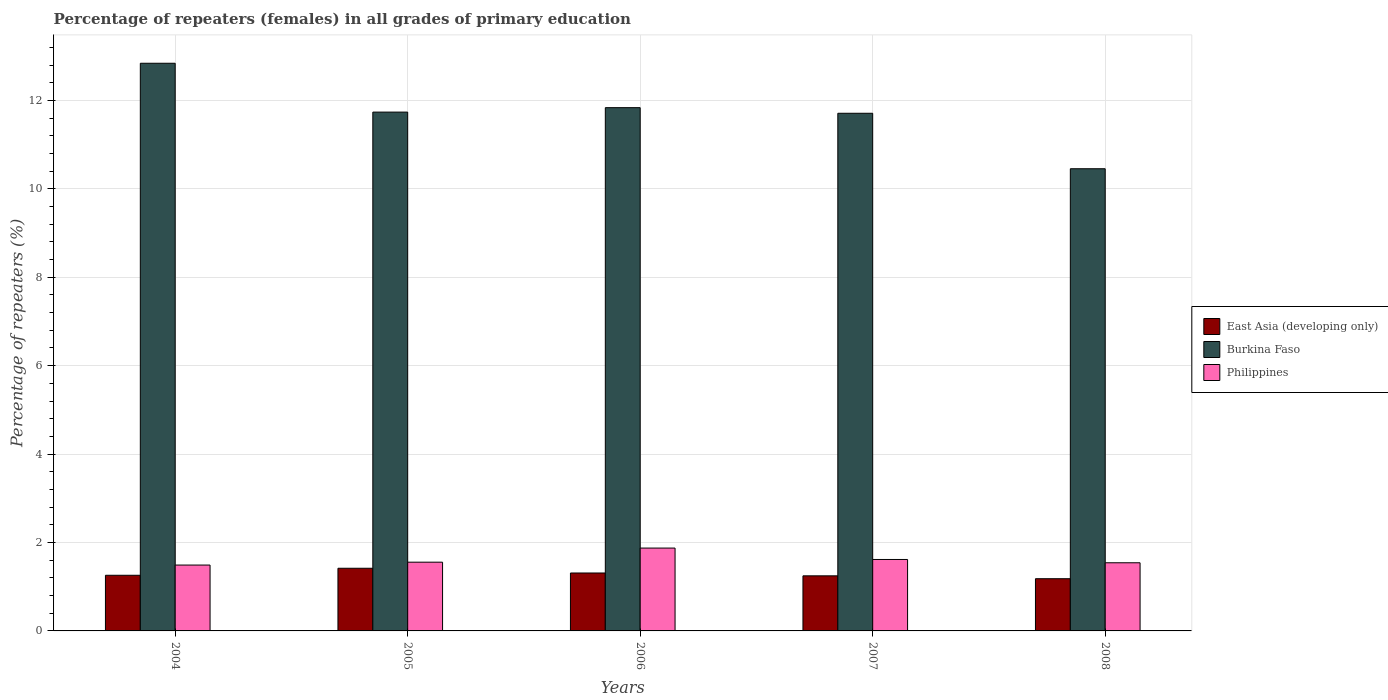How many different coloured bars are there?
Provide a succinct answer. 3. How many groups of bars are there?
Ensure brevity in your answer.  5. Are the number of bars on each tick of the X-axis equal?
Your answer should be compact. Yes. How many bars are there on the 2nd tick from the right?
Offer a terse response. 3. What is the label of the 3rd group of bars from the left?
Give a very brief answer. 2006. What is the percentage of repeaters (females) in Burkina Faso in 2004?
Provide a short and direct response. 12.84. Across all years, what is the maximum percentage of repeaters (females) in Philippines?
Your answer should be compact. 1.87. Across all years, what is the minimum percentage of repeaters (females) in Philippines?
Provide a succinct answer. 1.49. In which year was the percentage of repeaters (females) in Burkina Faso maximum?
Provide a short and direct response. 2004. In which year was the percentage of repeaters (females) in Philippines minimum?
Keep it short and to the point. 2004. What is the total percentage of repeaters (females) in Burkina Faso in the graph?
Your answer should be compact. 58.57. What is the difference between the percentage of repeaters (females) in Burkina Faso in 2006 and that in 2007?
Your answer should be compact. 0.13. What is the difference between the percentage of repeaters (females) in Philippines in 2008 and the percentage of repeaters (females) in East Asia (developing only) in 2004?
Provide a short and direct response. 0.28. What is the average percentage of repeaters (females) in Philippines per year?
Ensure brevity in your answer.  1.62. In the year 2005, what is the difference between the percentage of repeaters (females) in Burkina Faso and percentage of repeaters (females) in Philippines?
Offer a very short reply. 10.18. What is the ratio of the percentage of repeaters (females) in Burkina Faso in 2005 to that in 2006?
Your response must be concise. 0.99. Is the percentage of repeaters (females) in Burkina Faso in 2004 less than that in 2007?
Your answer should be very brief. No. What is the difference between the highest and the second highest percentage of repeaters (females) in Burkina Faso?
Your answer should be compact. 1. What is the difference between the highest and the lowest percentage of repeaters (females) in East Asia (developing only)?
Make the answer very short. 0.24. In how many years, is the percentage of repeaters (females) in Philippines greater than the average percentage of repeaters (females) in Philippines taken over all years?
Offer a very short reply. 2. What does the 2nd bar from the left in 2006 represents?
Your response must be concise. Burkina Faso. What does the 3rd bar from the right in 2006 represents?
Keep it short and to the point. East Asia (developing only). Are all the bars in the graph horizontal?
Ensure brevity in your answer.  No. What is the difference between two consecutive major ticks on the Y-axis?
Offer a very short reply. 2. Are the values on the major ticks of Y-axis written in scientific E-notation?
Your answer should be very brief. No. Does the graph contain any zero values?
Your answer should be very brief. No. Does the graph contain grids?
Give a very brief answer. Yes. Where does the legend appear in the graph?
Offer a terse response. Center right. What is the title of the graph?
Give a very brief answer. Percentage of repeaters (females) in all grades of primary education. Does "Tunisia" appear as one of the legend labels in the graph?
Give a very brief answer. No. What is the label or title of the Y-axis?
Your response must be concise. Percentage of repeaters (%). What is the Percentage of repeaters (%) in East Asia (developing only) in 2004?
Provide a short and direct response. 1.26. What is the Percentage of repeaters (%) in Burkina Faso in 2004?
Give a very brief answer. 12.84. What is the Percentage of repeaters (%) in Philippines in 2004?
Your answer should be compact. 1.49. What is the Percentage of repeaters (%) of East Asia (developing only) in 2005?
Provide a short and direct response. 1.42. What is the Percentage of repeaters (%) of Burkina Faso in 2005?
Ensure brevity in your answer.  11.73. What is the Percentage of repeaters (%) of Philippines in 2005?
Your answer should be compact. 1.55. What is the Percentage of repeaters (%) in East Asia (developing only) in 2006?
Ensure brevity in your answer.  1.31. What is the Percentage of repeaters (%) of Burkina Faso in 2006?
Give a very brief answer. 11.84. What is the Percentage of repeaters (%) in Philippines in 2006?
Make the answer very short. 1.87. What is the Percentage of repeaters (%) in East Asia (developing only) in 2007?
Provide a short and direct response. 1.25. What is the Percentage of repeaters (%) of Burkina Faso in 2007?
Your response must be concise. 11.71. What is the Percentage of repeaters (%) in Philippines in 2007?
Ensure brevity in your answer.  1.62. What is the Percentage of repeaters (%) in East Asia (developing only) in 2008?
Keep it short and to the point. 1.18. What is the Percentage of repeaters (%) in Burkina Faso in 2008?
Give a very brief answer. 10.45. What is the Percentage of repeaters (%) in Philippines in 2008?
Your answer should be compact. 1.54. Across all years, what is the maximum Percentage of repeaters (%) of East Asia (developing only)?
Provide a short and direct response. 1.42. Across all years, what is the maximum Percentage of repeaters (%) of Burkina Faso?
Your response must be concise. 12.84. Across all years, what is the maximum Percentage of repeaters (%) in Philippines?
Provide a succinct answer. 1.87. Across all years, what is the minimum Percentage of repeaters (%) of East Asia (developing only)?
Make the answer very short. 1.18. Across all years, what is the minimum Percentage of repeaters (%) in Burkina Faso?
Keep it short and to the point. 10.45. Across all years, what is the minimum Percentage of repeaters (%) of Philippines?
Keep it short and to the point. 1.49. What is the total Percentage of repeaters (%) in East Asia (developing only) in the graph?
Your answer should be very brief. 6.41. What is the total Percentage of repeaters (%) of Burkina Faso in the graph?
Make the answer very short. 58.57. What is the total Percentage of repeaters (%) of Philippines in the graph?
Provide a succinct answer. 8.08. What is the difference between the Percentage of repeaters (%) in East Asia (developing only) in 2004 and that in 2005?
Your answer should be very brief. -0.16. What is the difference between the Percentage of repeaters (%) in Burkina Faso in 2004 and that in 2005?
Your answer should be compact. 1.1. What is the difference between the Percentage of repeaters (%) in Philippines in 2004 and that in 2005?
Offer a very short reply. -0.06. What is the difference between the Percentage of repeaters (%) of East Asia (developing only) in 2004 and that in 2006?
Give a very brief answer. -0.05. What is the difference between the Percentage of repeaters (%) in Philippines in 2004 and that in 2006?
Offer a terse response. -0.38. What is the difference between the Percentage of repeaters (%) of East Asia (developing only) in 2004 and that in 2007?
Offer a very short reply. 0.01. What is the difference between the Percentage of repeaters (%) of Burkina Faso in 2004 and that in 2007?
Your response must be concise. 1.13. What is the difference between the Percentage of repeaters (%) of Philippines in 2004 and that in 2007?
Offer a terse response. -0.13. What is the difference between the Percentage of repeaters (%) of East Asia (developing only) in 2004 and that in 2008?
Keep it short and to the point. 0.08. What is the difference between the Percentage of repeaters (%) in Burkina Faso in 2004 and that in 2008?
Your answer should be very brief. 2.39. What is the difference between the Percentage of repeaters (%) in Philippines in 2004 and that in 2008?
Ensure brevity in your answer.  -0.05. What is the difference between the Percentage of repeaters (%) of East Asia (developing only) in 2005 and that in 2006?
Ensure brevity in your answer.  0.11. What is the difference between the Percentage of repeaters (%) in Burkina Faso in 2005 and that in 2006?
Keep it short and to the point. -0.1. What is the difference between the Percentage of repeaters (%) of Philippines in 2005 and that in 2006?
Ensure brevity in your answer.  -0.32. What is the difference between the Percentage of repeaters (%) in East Asia (developing only) in 2005 and that in 2007?
Make the answer very short. 0.17. What is the difference between the Percentage of repeaters (%) of Burkina Faso in 2005 and that in 2007?
Make the answer very short. 0.03. What is the difference between the Percentage of repeaters (%) of Philippines in 2005 and that in 2007?
Your answer should be compact. -0.06. What is the difference between the Percentage of repeaters (%) of East Asia (developing only) in 2005 and that in 2008?
Ensure brevity in your answer.  0.24. What is the difference between the Percentage of repeaters (%) of Burkina Faso in 2005 and that in 2008?
Your answer should be very brief. 1.28. What is the difference between the Percentage of repeaters (%) in Philippines in 2005 and that in 2008?
Offer a terse response. 0.01. What is the difference between the Percentage of repeaters (%) of East Asia (developing only) in 2006 and that in 2007?
Provide a short and direct response. 0.06. What is the difference between the Percentage of repeaters (%) of Burkina Faso in 2006 and that in 2007?
Ensure brevity in your answer.  0.13. What is the difference between the Percentage of repeaters (%) of Philippines in 2006 and that in 2007?
Make the answer very short. 0.26. What is the difference between the Percentage of repeaters (%) of East Asia (developing only) in 2006 and that in 2008?
Give a very brief answer. 0.13. What is the difference between the Percentage of repeaters (%) in Burkina Faso in 2006 and that in 2008?
Ensure brevity in your answer.  1.38. What is the difference between the Percentage of repeaters (%) of Philippines in 2006 and that in 2008?
Keep it short and to the point. 0.33. What is the difference between the Percentage of repeaters (%) of East Asia (developing only) in 2007 and that in 2008?
Provide a succinct answer. 0.07. What is the difference between the Percentage of repeaters (%) of Burkina Faso in 2007 and that in 2008?
Offer a terse response. 1.25. What is the difference between the Percentage of repeaters (%) in Philippines in 2007 and that in 2008?
Provide a short and direct response. 0.07. What is the difference between the Percentage of repeaters (%) of East Asia (developing only) in 2004 and the Percentage of repeaters (%) of Burkina Faso in 2005?
Offer a very short reply. -10.48. What is the difference between the Percentage of repeaters (%) of East Asia (developing only) in 2004 and the Percentage of repeaters (%) of Philippines in 2005?
Offer a terse response. -0.3. What is the difference between the Percentage of repeaters (%) of Burkina Faso in 2004 and the Percentage of repeaters (%) of Philippines in 2005?
Your answer should be very brief. 11.28. What is the difference between the Percentage of repeaters (%) in East Asia (developing only) in 2004 and the Percentage of repeaters (%) in Burkina Faso in 2006?
Your answer should be very brief. -10.58. What is the difference between the Percentage of repeaters (%) of East Asia (developing only) in 2004 and the Percentage of repeaters (%) of Philippines in 2006?
Keep it short and to the point. -0.62. What is the difference between the Percentage of repeaters (%) in Burkina Faso in 2004 and the Percentage of repeaters (%) in Philippines in 2006?
Your answer should be compact. 10.97. What is the difference between the Percentage of repeaters (%) of East Asia (developing only) in 2004 and the Percentage of repeaters (%) of Burkina Faso in 2007?
Your response must be concise. -10.45. What is the difference between the Percentage of repeaters (%) in East Asia (developing only) in 2004 and the Percentage of repeaters (%) in Philippines in 2007?
Ensure brevity in your answer.  -0.36. What is the difference between the Percentage of repeaters (%) of Burkina Faso in 2004 and the Percentage of repeaters (%) of Philippines in 2007?
Give a very brief answer. 11.22. What is the difference between the Percentage of repeaters (%) in East Asia (developing only) in 2004 and the Percentage of repeaters (%) in Burkina Faso in 2008?
Offer a very short reply. -9.2. What is the difference between the Percentage of repeaters (%) of East Asia (developing only) in 2004 and the Percentage of repeaters (%) of Philippines in 2008?
Your answer should be very brief. -0.28. What is the difference between the Percentage of repeaters (%) in Burkina Faso in 2004 and the Percentage of repeaters (%) in Philippines in 2008?
Offer a very short reply. 11.3. What is the difference between the Percentage of repeaters (%) in East Asia (developing only) in 2005 and the Percentage of repeaters (%) in Burkina Faso in 2006?
Make the answer very short. -10.42. What is the difference between the Percentage of repeaters (%) in East Asia (developing only) in 2005 and the Percentage of repeaters (%) in Philippines in 2006?
Your response must be concise. -0.46. What is the difference between the Percentage of repeaters (%) of Burkina Faso in 2005 and the Percentage of repeaters (%) of Philippines in 2006?
Your answer should be very brief. 9.86. What is the difference between the Percentage of repeaters (%) of East Asia (developing only) in 2005 and the Percentage of repeaters (%) of Burkina Faso in 2007?
Offer a very short reply. -10.29. What is the difference between the Percentage of repeaters (%) in East Asia (developing only) in 2005 and the Percentage of repeaters (%) in Philippines in 2007?
Ensure brevity in your answer.  -0.2. What is the difference between the Percentage of repeaters (%) of Burkina Faso in 2005 and the Percentage of repeaters (%) of Philippines in 2007?
Offer a terse response. 10.12. What is the difference between the Percentage of repeaters (%) in East Asia (developing only) in 2005 and the Percentage of repeaters (%) in Burkina Faso in 2008?
Offer a terse response. -9.04. What is the difference between the Percentage of repeaters (%) in East Asia (developing only) in 2005 and the Percentage of repeaters (%) in Philippines in 2008?
Provide a succinct answer. -0.12. What is the difference between the Percentage of repeaters (%) of Burkina Faso in 2005 and the Percentage of repeaters (%) of Philippines in 2008?
Your answer should be compact. 10.19. What is the difference between the Percentage of repeaters (%) in East Asia (developing only) in 2006 and the Percentage of repeaters (%) in Burkina Faso in 2007?
Give a very brief answer. -10.4. What is the difference between the Percentage of repeaters (%) in East Asia (developing only) in 2006 and the Percentage of repeaters (%) in Philippines in 2007?
Offer a terse response. -0.31. What is the difference between the Percentage of repeaters (%) in Burkina Faso in 2006 and the Percentage of repeaters (%) in Philippines in 2007?
Provide a succinct answer. 10.22. What is the difference between the Percentage of repeaters (%) in East Asia (developing only) in 2006 and the Percentage of repeaters (%) in Burkina Faso in 2008?
Offer a terse response. -9.14. What is the difference between the Percentage of repeaters (%) in East Asia (developing only) in 2006 and the Percentage of repeaters (%) in Philippines in 2008?
Ensure brevity in your answer.  -0.23. What is the difference between the Percentage of repeaters (%) of Burkina Faso in 2006 and the Percentage of repeaters (%) of Philippines in 2008?
Your answer should be compact. 10.29. What is the difference between the Percentage of repeaters (%) in East Asia (developing only) in 2007 and the Percentage of repeaters (%) in Burkina Faso in 2008?
Your answer should be very brief. -9.21. What is the difference between the Percentage of repeaters (%) in East Asia (developing only) in 2007 and the Percentage of repeaters (%) in Philippines in 2008?
Provide a short and direct response. -0.3. What is the difference between the Percentage of repeaters (%) of Burkina Faso in 2007 and the Percentage of repeaters (%) of Philippines in 2008?
Give a very brief answer. 10.17. What is the average Percentage of repeaters (%) in East Asia (developing only) per year?
Give a very brief answer. 1.28. What is the average Percentage of repeaters (%) in Burkina Faso per year?
Offer a terse response. 11.71. What is the average Percentage of repeaters (%) of Philippines per year?
Your answer should be compact. 1.62. In the year 2004, what is the difference between the Percentage of repeaters (%) of East Asia (developing only) and Percentage of repeaters (%) of Burkina Faso?
Your response must be concise. -11.58. In the year 2004, what is the difference between the Percentage of repeaters (%) in East Asia (developing only) and Percentage of repeaters (%) in Philippines?
Offer a very short reply. -0.23. In the year 2004, what is the difference between the Percentage of repeaters (%) of Burkina Faso and Percentage of repeaters (%) of Philippines?
Your response must be concise. 11.35. In the year 2005, what is the difference between the Percentage of repeaters (%) in East Asia (developing only) and Percentage of repeaters (%) in Burkina Faso?
Your answer should be compact. -10.32. In the year 2005, what is the difference between the Percentage of repeaters (%) in East Asia (developing only) and Percentage of repeaters (%) in Philippines?
Give a very brief answer. -0.14. In the year 2005, what is the difference between the Percentage of repeaters (%) of Burkina Faso and Percentage of repeaters (%) of Philippines?
Provide a succinct answer. 10.18. In the year 2006, what is the difference between the Percentage of repeaters (%) in East Asia (developing only) and Percentage of repeaters (%) in Burkina Faso?
Give a very brief answer. -10.53. In the year 2006, what is the difference between the Percentage of repeaters (%) of East Asia (developing only) and Percentage of repeaters (%) of Philippines?
Offer a terse response. -0.56. In the year 2006, what is the difference between the Percentage of repeaters (%) of Burkina Faso and Percentage of repeaters (%) of Philippines?
Ensure brevity in your answer.  9.96. In the year 2007, what is the difference between the Percentage of repeaters (%) of East Asia (developing only) and Percentage of repeaters (%) of Burkina Faso?
Your answer should be compact. -10.46. In the year 2007, what is the difference between the Percentage of repeaters (%) of East Asia (developing only) and Percentage of repeaters (%) of Philippines?
Offer a very short reply. -0.37. In the year 2007, what is the difference between the Percentage of repeaters (%) of Burkina Faso and Percentage of repeaters (%) of Philippines?
Ensure brevity in your answer.  10.09. In the year 2008, what is the difference between the Percentage of repeaters (%) of East Asia (developing only) and Percentage of repeaters (%) of Burkina Faso?
Keep it short and to the point. -9.27. In the year 2008, what is the difference between the Percentage of repeaters (%) of East Asia (developing only) and Percentage of repeaters (%) of Philippines?
Make the answer very short. -0.36. In the year 2008, what is the difference between the Percentage of repeaters (%) of Burkina Faso and Percentage of repeaters (%) of Philippines?
Keep it short and to the point. 8.91. What is the ratio of the Percentage of repeaters (%) of East Asia (developing only) in 2004 to that in 2005?
Offer a terse response. 0.89. What is the ratio of the Percentage of repeaters (%) in Burkina Faso in 2004 to that in 2005?
Offer a very short reply. 1.09. What is the ratio of the Percentage of repeaters (%) in Philippines in 2004 to that in 2005?
Provide a short and direct response. 0.96. What is the ratio of the Percentage of repeaters (%) of East Asia (developing only) in 2004 to that in 2006?
Keep it short and to the point. 0.96. What is the ratio of the Percentage of repeaters (%) in Burkina Faso in 2004 to that in 2006?
Your response must be concise. 1.08. What is the ratio of the Percentage of repeaters (%) of Philippines in 2004 to that in 2006?
Provide a succinct answer. 0.8. What is the ratio of the Percentage of repeaters (%) in East Asia (developing only) in 2004 to that in 2007?
Give a very brief answer. 1.01. What is the ratio of the Percentage of repeaters (%) of Burkina Faso in 2004 to that in 2007?
Give a very brief answer. 1.1. What is the ratio of the Percentage of repeaters (%) in Philippines in 2004 to that in 2007?
Your answer should be compact. 0.92. What is the ratio of the Percentage of repeaters (%) of East Asia (developing only) in 2004 to that in 2008?
Your answer should be compact. 1.07. What is the ratio of the Percentage of repeaters (%) in Burkina Faso in 2004 to that in 2008?
Offer a very short reply. 1.23. What is the ratio of the Percentage of repeaters (%) in Philippines in 2004 to that in 2008?
Provide a short and direct response. 0.97. What is the ratio of the Percentage of repeaters (%) of East Asia (developing only) in 2005 to that in 2006?
Provide a succinct answer. 1.08. What is the ratio of the Percentage of repeaters (%) of Philippines in 2005 to that in 2006?
Provide a succinct answer. 0.83. What is the ratio of the Percentage of repeaters (%) of East Asia (developing only) in 2005 to that in 2007?
Offer a terse response. 1.14. What is the ratio of the Percentage of repeaters (%) of Burkina Faso in 2005 to that in 2007?
Give a very brief answer. 1. What is the ratio of the Percentage of repeaters (%) of Philippines in 2005 to that in 2007?
Your response must be concise. 0.96. What is the ratio of the Percentage of repeaters (%) in East Asia (developing only) in 2005 to that in 2008?
Provide a short and direct response. 1.2. What is the ratio of the Percentage of repeaters (%) of Burkina Faso in 2005 to that in 2008?
Give a very brief answer. 1.12. What is the ratio of the Percentage of repeaters (%) of Philippines in 2005 to that in 2008?
Give a very brief answer. 1.01. What is the ratio of the Percentage of repeaters (%) of East Asia (developing only) in 2006 to that in 2007?
Make the answer very short. 1.05. What is the ratio of the Percentage of repeaters (%) of Burkina Faso in 2006 to that in 2007?
Provide a short and direct response. 1.01. What is the ratio of the Percentage of repeaters (%) in Philippines in 2006 to that in 2007?
Your response must be concise. 1.16. What is the ratio of the Percentage of repeaters (%) in East Asia (developing only) in 2006 to that in 2008?
Your answer should be very brief. 1.11. What is the ratio of the Percentage of repeaters (%) of Burkina Faso in 2006 to that in 2008?
Offer a very short reply. 1.13. What is the ratio of the Percentage of repeaters (%) in Philippines in 2006 to that in 2008?
Keep it short and to the point. 1.22. What is the ratio of the Percentage of repeaters (%) in East Asia (developing only) in 2007 to that in 2008?
Keep it short and to the point. 1.06. What is the ratio of the Percentage of repeaters (%) in Burkina Faso in 2007 to that in 2008?
Offer a terse response. 1.12. What is the ratio of the Percentage of repeaters (%) of Philippines in 2007 to that in 2008?
Offer a terse response. 1.05. What is the difference between the highest and the second highest Percentage of repeaters (%) of East Asia (developing only)?
Provide a short and direct response. 0.11. What is the difference between the highest and the second highest Percentage of repeaters (%) of Burkina Faso?
Offer a very short reply. 1. What is the difference between the highest and the second highest Percentage of repeaters (%) of Philippines?
Your answer should be compact. 0.26. What is the difference between the highest and the lowest Percentage of repeaters (%) in East Asia (developing only)?
Ensure brevity in your answer.  0.24. What is the difference between the highest and the lowest Percentage of repeaters (%) of Burkina Faso?
Offer a terse response. 2.39. What is the difference between the highest and the lowest Percentage of repeaters (%) of Philippines?
Provide a succinct answer. 0.38. 